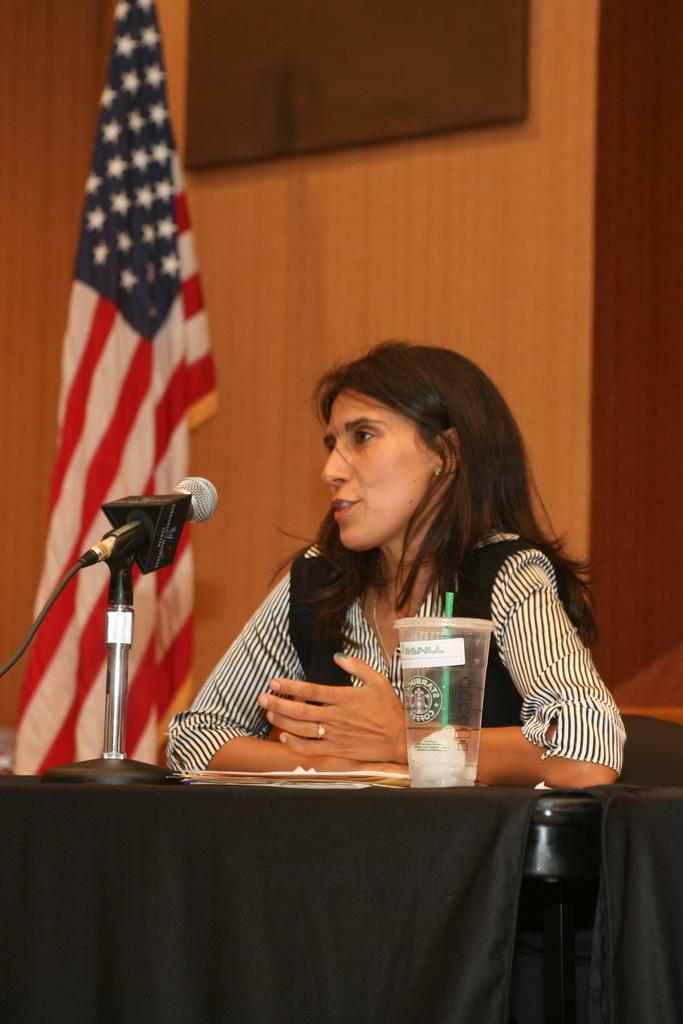What is the woman in the image doing? The woman is sitting on a chair in the image. What is in front of the woman? The woman is in front of a table. What objects are on the table? There is a microphone, papers, and a glass on the table. What can be seen on the left side of the image? There is a United States flag and a screen on the left side of the image. What holiday is being celebrated in the image? There is no indication of a holiday being celebrated in the image. Can you tell me how the woman is running in the image? The woman is not running in the image; she is sitting on a chair. 